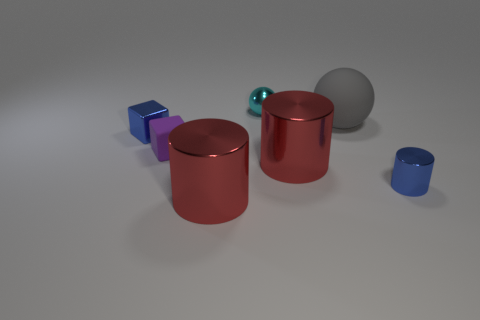What is the material of the tiny thing that is to the right of the red cylinder that is on the right side of the small cyan metal sphere?
Your answer should be compact. Metal. Are there any blocks of the same color as the tiny metal cylinder?
Give a very brief answer. Yes. The matte block that is the same size as the cyan shiny object is what color?
Provide a short and direct response. Purple. What material is the blue thing on the right side of the blue object that is to the left of the big object on the left side of the cyan metal ball?
Provide a succinct answer. Metal. Do the small metallic cylinder and the block that is in front of the blue shiny cube have the same color?
Offer a very short reply. No. What number of things are objects that are in front of the purple thing or tiny blue things that are on the left side of the big sphere?
Ensure brevity in your answer.  4. There is a big red object in front of the big red metallic thing that is behind the small metal cylinder; what shape is it?
Your answer should be very brief. Cylinder. Are there any tiny blocks made of the same material as the small cyan sphere?
Provide a short and direct response. Yes. What color is the other small thing that is the same shape as the purple object?
Provide a short and direct response. Blue. Are there fewer gray things left of the small rubber cube than small things on the right side of the big matte object?
Ensure brevity in your answer.  Yes. 